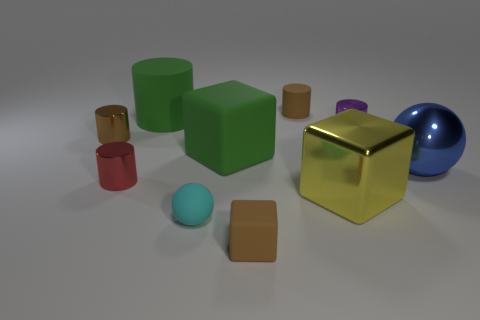What is the size of the cylinder that is the same color as the big rubber block?
Your response must be concise. Large. Is there a brown cylinder of the same size as the purple thing?
Your answer should be compact. Yes. There is a big metal ball; does it have the same color as the metal cylinder that is on the right side of the big green matte cylinder?
Provide a short and direct response. No. How many small metallic cylinders are on the right side of the brown rubber thing that is behind the purple thing?
Ensure brevity in your answer.  1. What color is the large block on the right side of the tiny rubber object that is behind the big blue ball?
Give a very brief answer. Yellow. What material is the small cylinder that is both in front of the tiny rubber cylinder and right of the red metallic cylinder?
Offer a terse response. Metal. Are there any other shiny things of the same shape as the purple metallic thing?
Provide a short and direct response. Yes. Does the big green matte object that is in front of the big matte cylinder have the same shape as the yellow object?
Ensure brevity in your answer.  Yes. How many tiny cylinders are both to the left of the brown cube and on the right side of the big yellow thing?
Offer a terse response. 0. There is a big green thing right of the tiny ball; what is its shape?
Offer a terse response. Cube. 